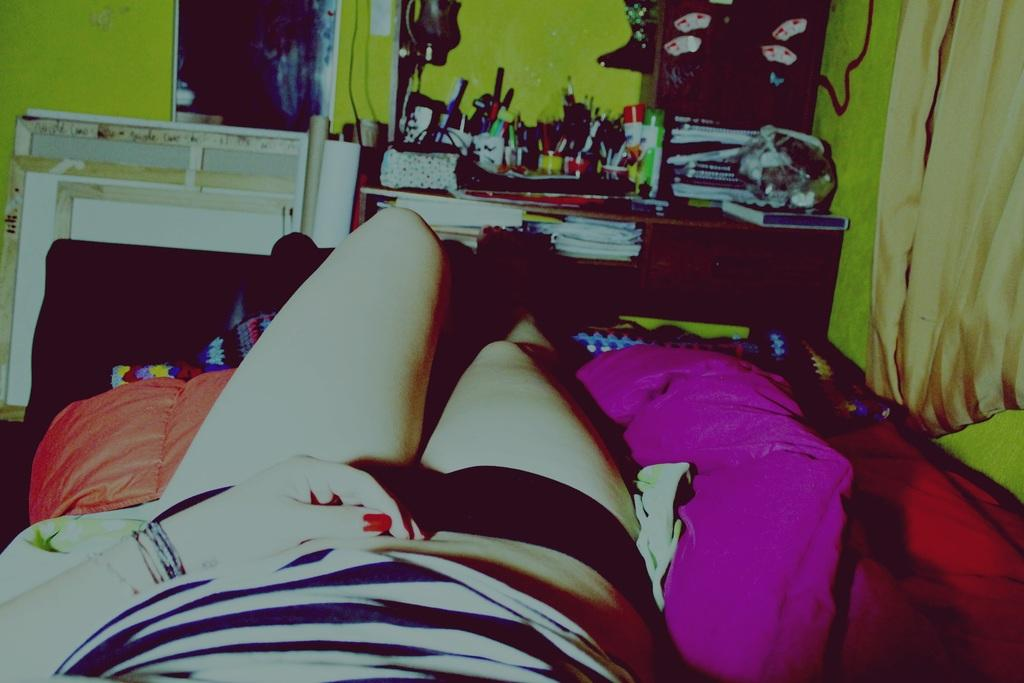What is the person in the image doing? There is a person sleeping on the bed in the image. What can be seen in the background of the image? There is a table in the background of the image. What items are on the table? On the table, there are pens, papers, bottles, and books. What type of friction can be observed between the person and the bed in the image? There is no friction observable between the person and the bed in the image, as the person is sleeping and not interacting with the bed in any way. 